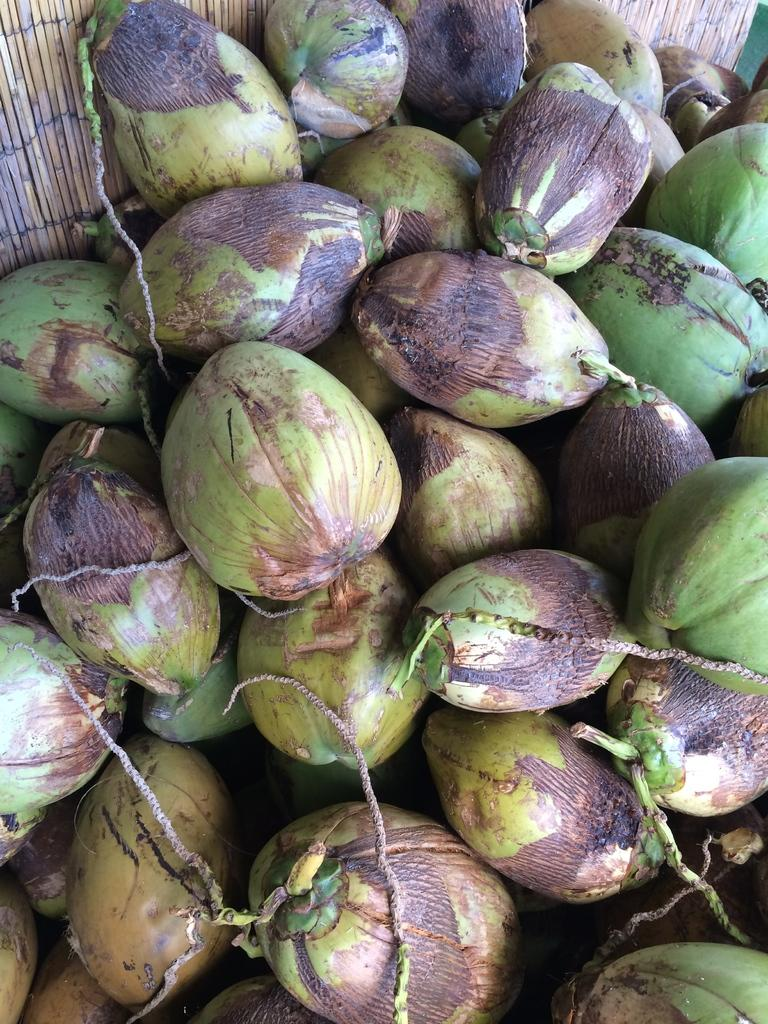What type of coconuts are visible in the image? There are green coconuts in the image. How are the coconuts arranged in the image? The coconuts are arranged on a mat. How many chairs are visible in the image? There are no chairs present in the image; it only features green coconuts arranged on a mat. What type of cable can be seen connecting the coconuts in the image? There is no cable connecting the coconuts in the image; they are simply arranged on a mat. 